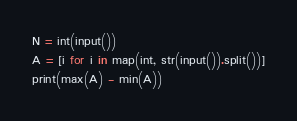<code> <loc_0><loc_0><loc_500><loc_500><_Python_>N = int(input())
A = [i for i in map(int, str(input()).split())]
print(max(A) - min(A))</code> 